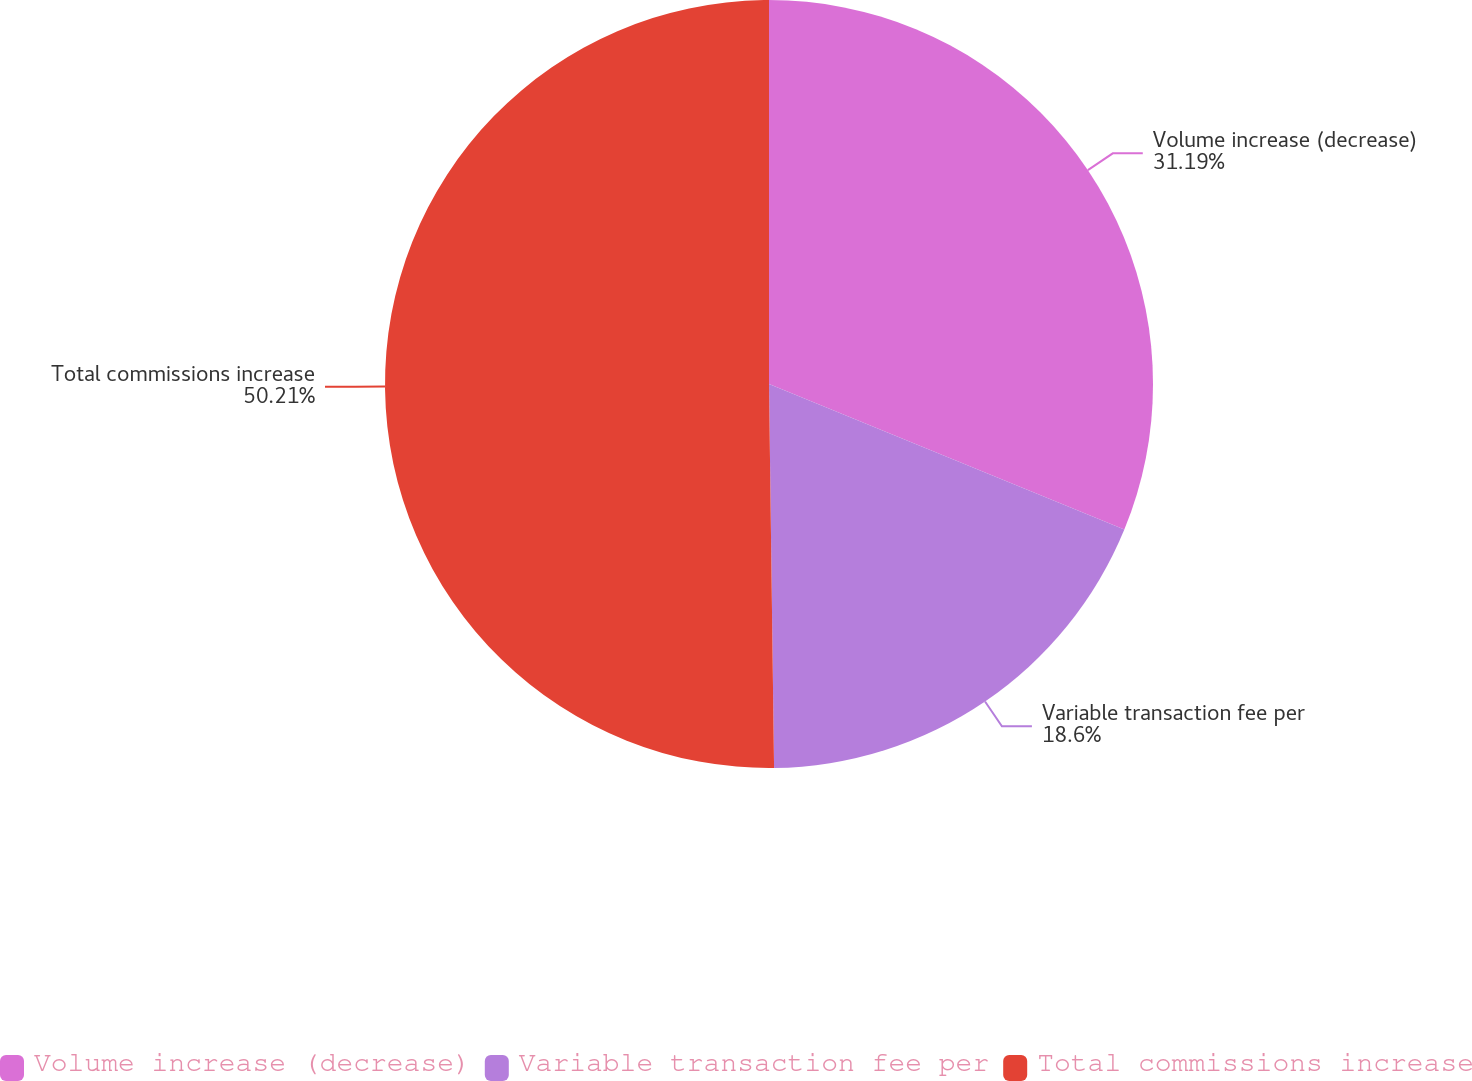Convert chart to OTSL. <chart><loc_0><loc_0><loc_500><loc_500><pie_chart><fcel>Volume increase (decrease)<fcel>Variable transaction fee per<fcel>Total commissions increase<nl><fcel>31.19%<fcel>18.6%<fcel>50.21%<nl></chart> 